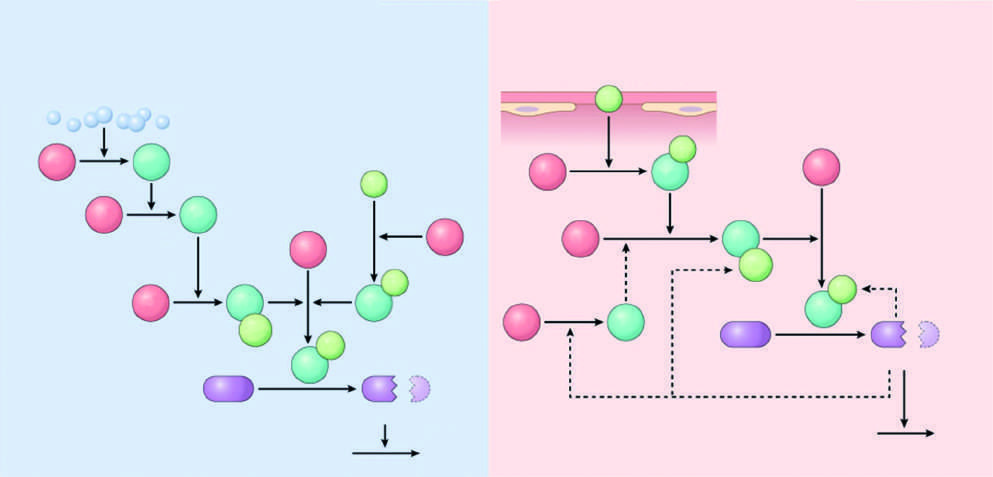s tissue factor the major initiator of coagulation, which is amplified by feedback loops involving thrombin in vivo?
Answer the question using a single word or phrase. Yes 